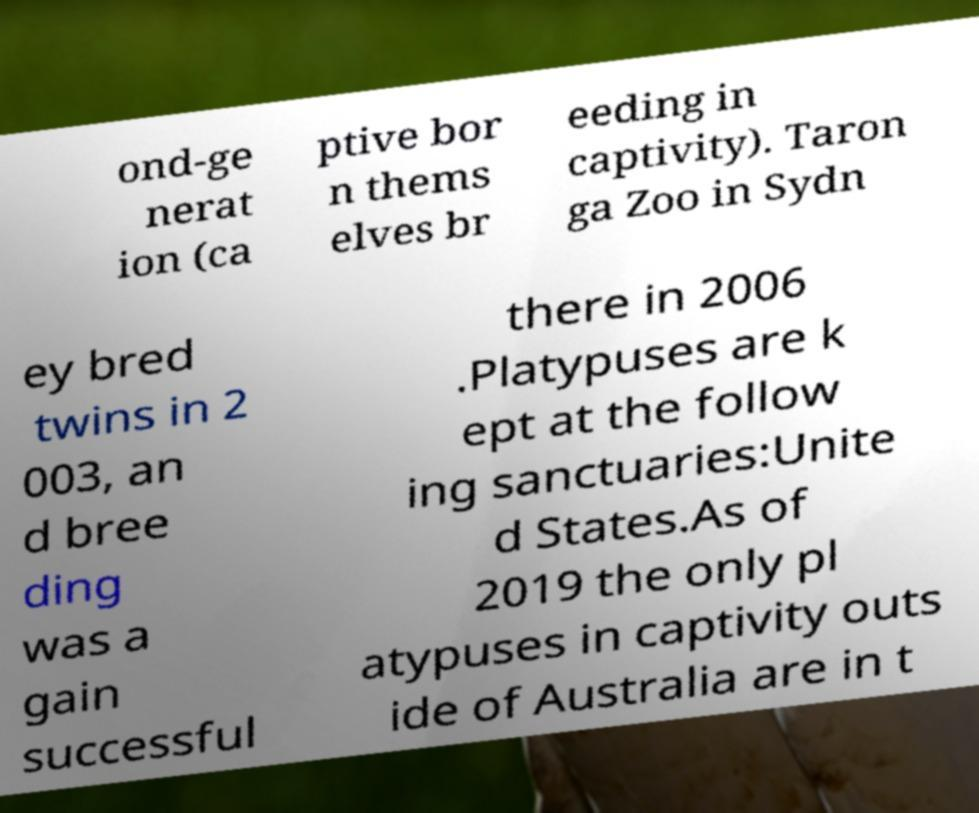For documentation purposes, I need the text within this image transcribed. Could you provide that? ond-ge nerat ion (ca ptive bor n thems elves br eeding in captivity). Taron ga Zoo in Sydn ey bred twins in 2 003, an d bree ding was a gain successful there in 2006 .Platypuses are k ept at the follow ing sanctuaries:Unite d States.As of 2019 the only pl atypuses in captivity outs ide of Australia are in t 